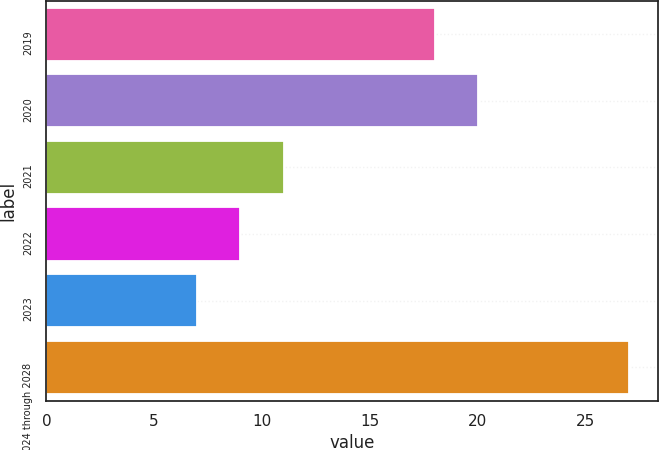Convert chart to OTSL. <chart><loc_0><loc_0><loc_500><loc_500><bar_chart><fcel>2019<fcel>2020<fcel>2021<fcel>2022<fcel>2023<fcel>2024 through 2028<nl><fcel>18<fcel>20<fcel>11<fcel>9<fcel>7<fcel>27<nl></chart> 